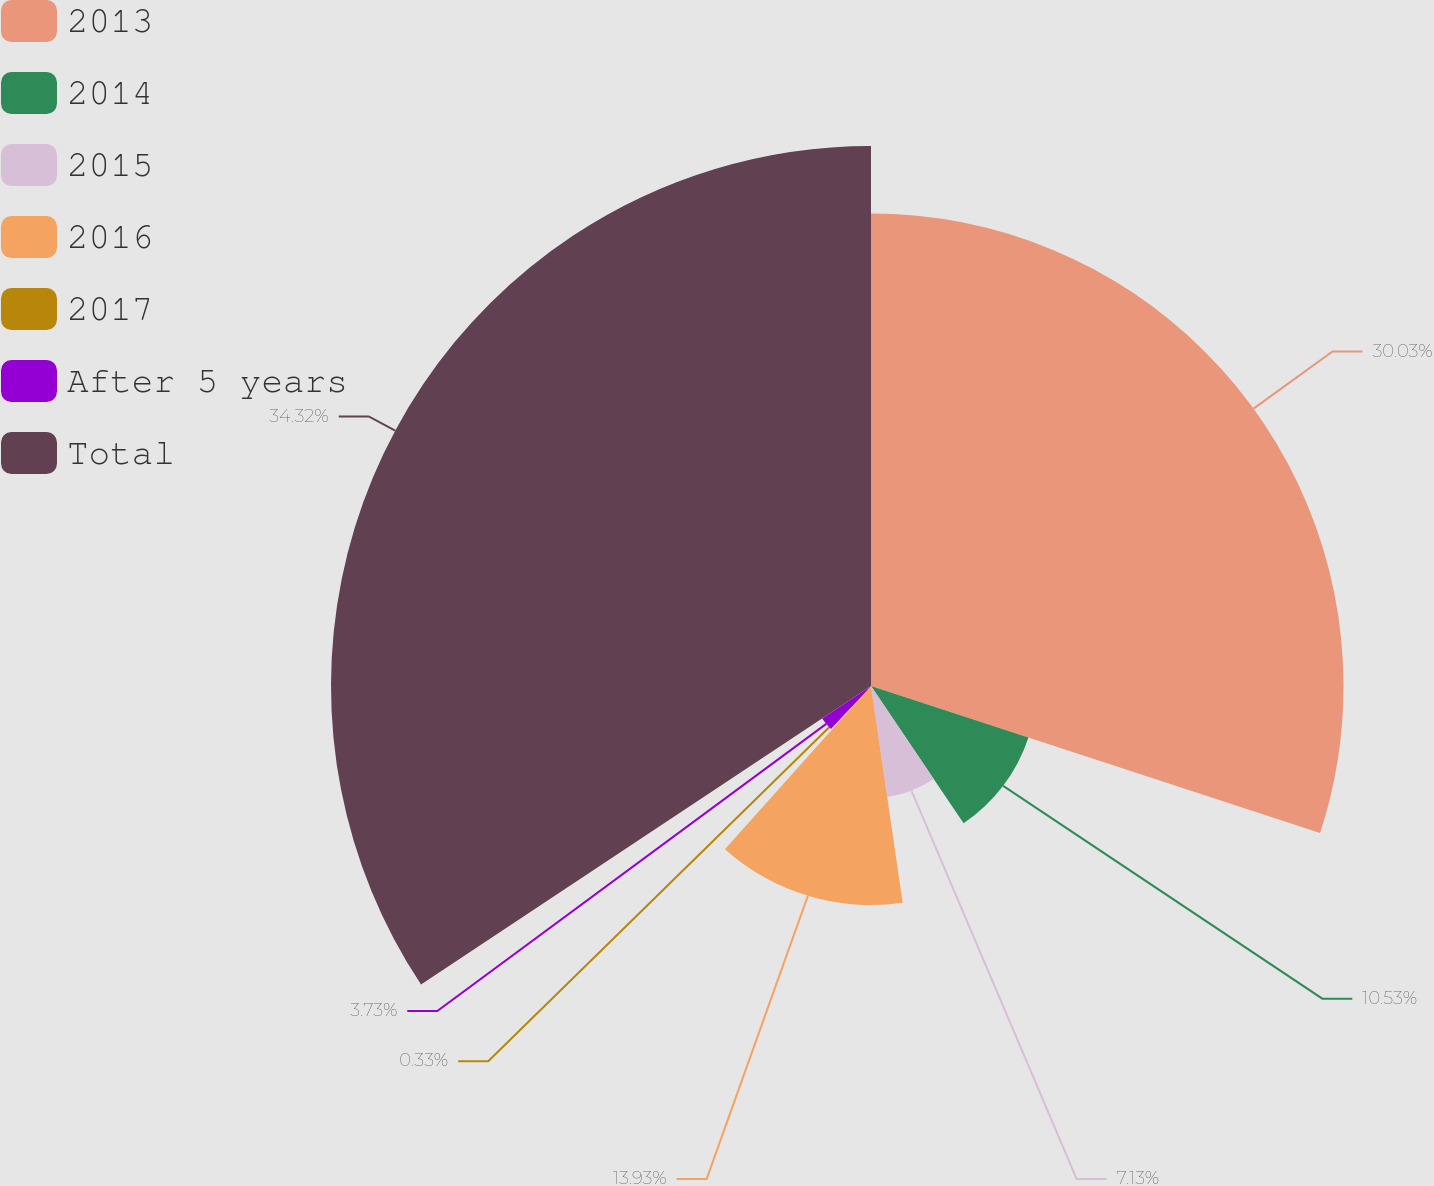<chart> <loc_0><loc_0><loc_500><loc_500><pie_chart><fcel>2013<fcel>2014<fcel>2015<fcel>2016<fcel>2017<fcel>After 5 years<fcel>Total<nl><fcel>30.04%<fcel>10.53%<fcel>7.13%<fcel>13.93%<fcel>0.33%<fcel>3.73%<fcel>34.33%<nl></chart> 